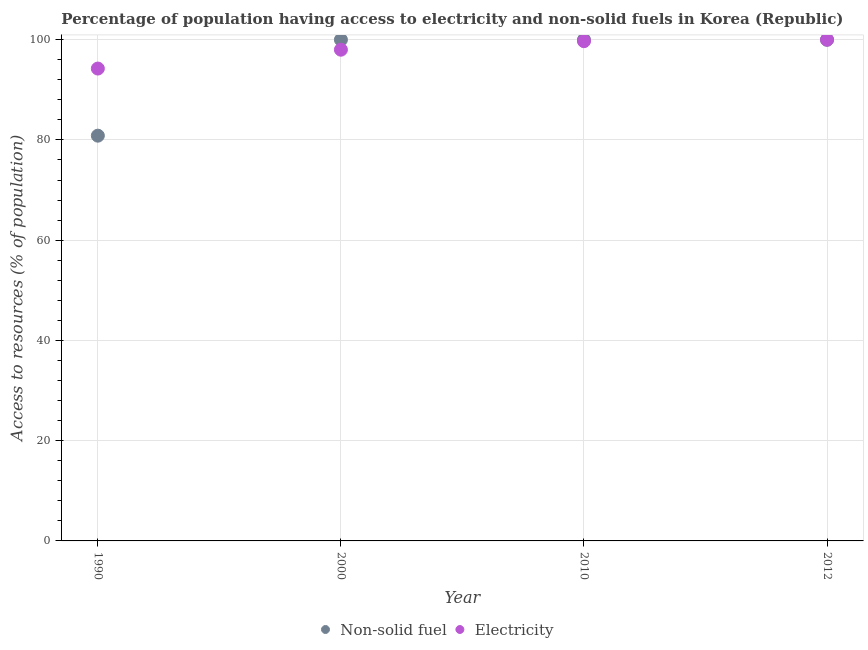What is the percentage of population having access to non-solid fuel in 2010?
Offer a terse response. 99.99. Across all years, what is the maximum percentage of population having access to non-solid fuel?
Your answer should be compact. 99.99. Across all years, what is the minimum percentage of population having access to non-solid fuel?
Give a very brief answer. 80.85. In which year was the percentage of population having access to non-solid fuel maximum?
Provide a succinct answer. 2000. What is the total percentage of population having access to electricity in the graph?
Your answer should be compact. 391.94. What is the difference between the percentage of population having access to electricity in 2000 and that in 2012?
Make the answer very short. -2. What is the difference between the percentage of population having access to non-solid fuel in 2010 and the percentage of population having access to electricity in 2000?
Make the answer very short. 1.99. What is the average percentage of population having access to electricity per year?
Your response must be concise. 97.98. In the year 1990, what is the difference between the percentage of population having access to electricity and percentage of population having access to non-solid fuel?
Give a very brief answer. 13.39. In how many years, is the percentage of population having access to electricity greater than 48 %?
Ensure brevity in your answer.  4. What is the ratio of the percentage of population having access to electricity in 1990 to that in 2010?
Your answer should be compact. 0.95. What is the difference between the highest and the lowest percentage of population having access to non-solid fuel?
Ensure brevity in your answer.  19.14. In how many years, is the percentage of population having access to non-solid fuel greater than the average percentage of population having access to non-solid fuel taken over all years?
Give a very brief answer. 3. Is the percentage of population having access to electricity strictly greater than the percentage of population having access to non-solid fuel over the years?
Ensure brevity in your answer.  No. Does the graph contain any zero values?
Your answer should be compact. No. What is the title of the graph?
Your answer should be compact. Percentage of population having access to electricity and non-solid fuels in Korea (Republic). Does "% of gross capital formation" appear as one of the legend labels in the graph?
Offer a very short reply. No. What is the label or title of the Y-axis?
Provide a short and direct response. Access to resources (% of population). What is the Access to resources (% of population) in Non-solid fuel in 1990?
Ensure brevity in your answer.  80.85. What is the Access to resources (% of population) of Electricity in 1990?
Ensure brevity in your answer.  94.24. What is the Access to resources (% of population) in Non-solid fuel in 2000?
Offer a terse response. 99.99. What is the Access to resources (% of population) in Non-solid fuel in 2010?
Give a very brief answer. 99.99. What is the Access to resources (% of population) in Electricity in 2010?
Offer a terse response. 99.7. What is the Access to resources (% of population) of Non-solid fuel in 2012?
Offer a very short reply. 99.99. Across all years, what is the maximum Access to resources (% of population) of Non-solid fuel?
Offer a very short reply. 99.99. Across all years, what is the minimum Access to resources (% of population) in Non-solid fuel?
Give a very brief answer. 80.85. Across all years, what is the minimum Access to resources (% of population) in Electricity?
Your response must be concise. 94.24. What is the total Access to resources (% of population) of Non-solid fuel in the graph?
Offer a terse response. 380.82. What is the total Access to resources (% of population) of Electricity in the graph?
Offer a very short reply. 391.94. What is the difference between the Access to resources (% of population) of Non-solid fuel in 1990 and that in 2000?
Provide a short and direct response. -19.14. What is the difference between the Access to resources (% of population) in Electricity in 1990 and that in 2000?
Keep it short and to the point. -3.76. What is the difference between the Access to resources (% of population) in Non-solid fuel in 1990 and that in 2010?
Provide a succinct answer. -19.14. What is the difference between the Access to resources (% of population) of Electricity in 1990 and that in 2010?
Your response must be concise. -5.46. What is the difference between the Access to resources (% of population) of Non-solid fuel in 1990 and that in 2012?
Give a very brief answer. -19.14. What is the difference between the Access to resources (% of population) of Electricity in 1990 and that in 2012?
Keep it short and to the point. -5.76. What is the difference between the Access to resources (% of population) in Electricity in 2000 and that in 2010?
Keep it short and to the point. -1.7. What is the difference between the Access to resources (% of population) of Electricity in 2000 and that in 2012?
Offer a very short reply. -2. What is the difference between the Access to resources (% of population) in Non-solid fuel in 1990 and the Access to resources (% of population) in Electricity in 2000?
Provide a short and direct response. -17.15. What is the difference between the Access to resources (% of population) in Non-solid fuel in 1990 and the Access to resources (% of population) in Electricity in 2010?
Provide a short and direct response. -18.85. What is the difference between the Access to resources (% of population) of Non-solid fuel in 1990 and the Access to resources (% of population) of Electricity in 2012?
Give a very brief answer. -19.15. What is the difference between the Access to resources (% of population) in Non-solid fuel in 2000 and the Access to resources (% of population) in Electricity in 2010?
Make the answer very short. 0.29. What is the difference between the Access to resources (% of population) of Non-solid fuel in 2000 and the Access to resources (% of population) of Electricity in 2012?
Your answer should be compact. -0.01. What is the difference between the Access to resources (% of population) in Non-solid fuel in 2010 and the Access to resources (% of population) in Electricity in 2012?
Offer a very short reply. -0.01. What is the average Access to resources (% of population) of Non-solid fuel per year?
Your answer should be compact. 95.2. What is the average Access to resources (% of population) of Electricity per year?
Provide a short and direct response. 97.98. In the year 1990, what is the difference between the Access to resources (% of population) of Non-solid fuel and Access to resources (% of population) of Electricity?
Your answer should be compact. -13.39. In the year 2000, what is the difference between the Access to resources (% of population) of Non-solid fuel and Access to resources (% of population) of Electricity?
Your answer should be very brief. 1.99. In the year 2010, what is the difference between the Access to resources (% of population) in Non-solid fuel and Access to resources (% of population) in Electricity?
Your response must be concise. 0.29. In the year 2012, what is the difference between the Access to resources (% of population) in Non-solid fuel and Access to resources (% of population) in Electricity?
Give a very brief answer. -0.01. What is the ratio of the Access to resources (% of population) of Non-solid fuel in 1990 to that in 2000?
Provide a short and direct response. 0.81. What is the ratio of the Access to resources (% of population) in Electricity in 1990 to that in 2000?
Give a very brief answer. 0.96. What is the ratio of the Access to resources (% of population) of Non-solid fuel in 1990 to that in 2010?
Give a very brief answer. 0.81. What is the ratio of the Access to resources (% of population) of Electricity in 1990 to that in 2010?
Ensure brevity in your answer.  0.95. What is the ratio of the Access to resources (% of population) in Non-solid fuel in 1990 to that in 2012?
Offer a very short reply. 0.81. What is the ratio of the Access to resources (% of population) of Electricity in 1990 to that in 2012?
Your response must be concise. 0.94. What is the ratio of the Access to resources (% of population) in Non-solid fuel in 2000 to that in 2010?
Make the answer very short. 1. What is the ratio of the Access to resources (% of population) of Electricity in 2000 to that in 2010?
Provide a short and direct response. 0.98. What is the difference between the highest and the lowest Access to resources (% of population) of Non-solid fuel?
Provide a short and direct response. 19.14. What is the difference between the highest and the lowest Access to resources (% of population) in Electricity?
Offer a very short reply. 5.76. 